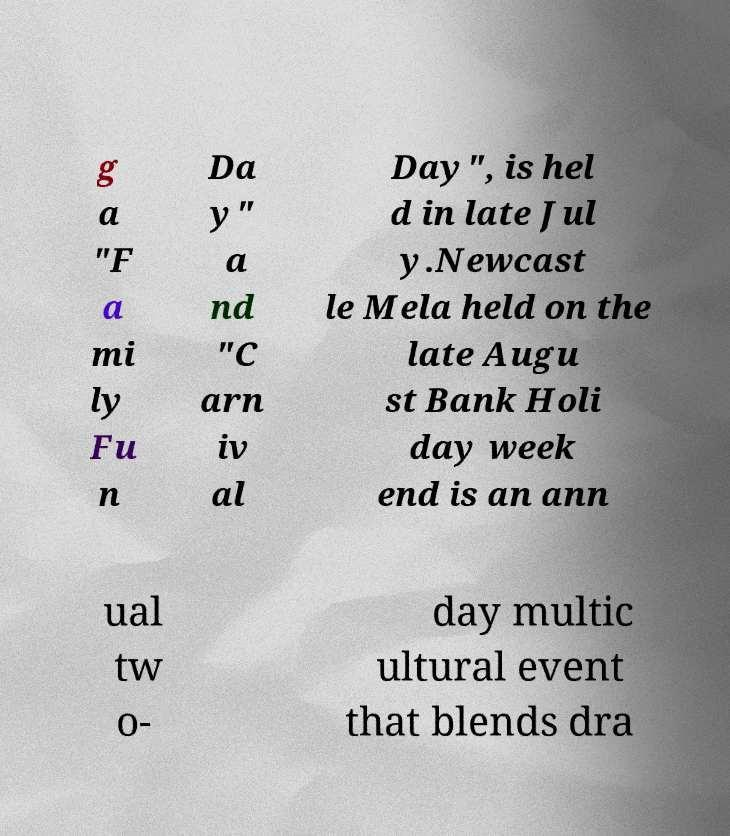Could you extract and type out the text from this image? g a "F a mi ly Fu n Da y" a nd "C arn iv al Day", is hel d in late Jul y.Newcast le Mela held on the late Augu st Bank Holi day week end is an ann ual tw o- day multic ultural event that blends dra 